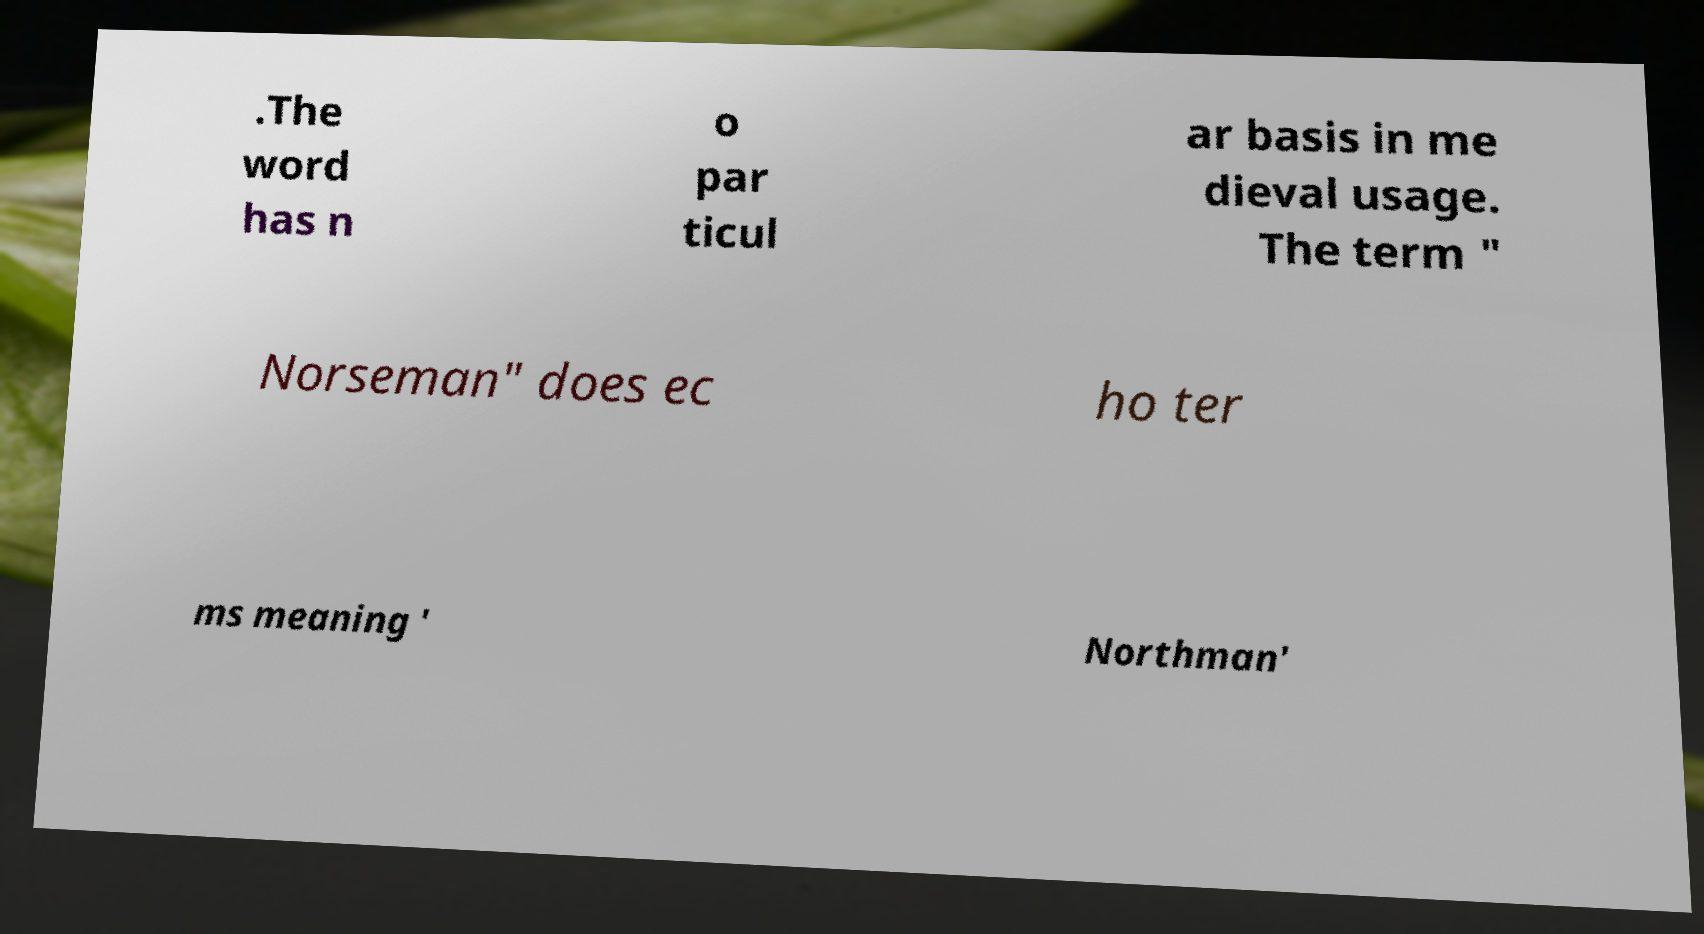Could you assist in decoding the text presented in this image and type it out clearly? .The word has n o par ticul ar basis in me dieval usage. The term " Norseman" does ec ho ter ms meaning ' Northman' 